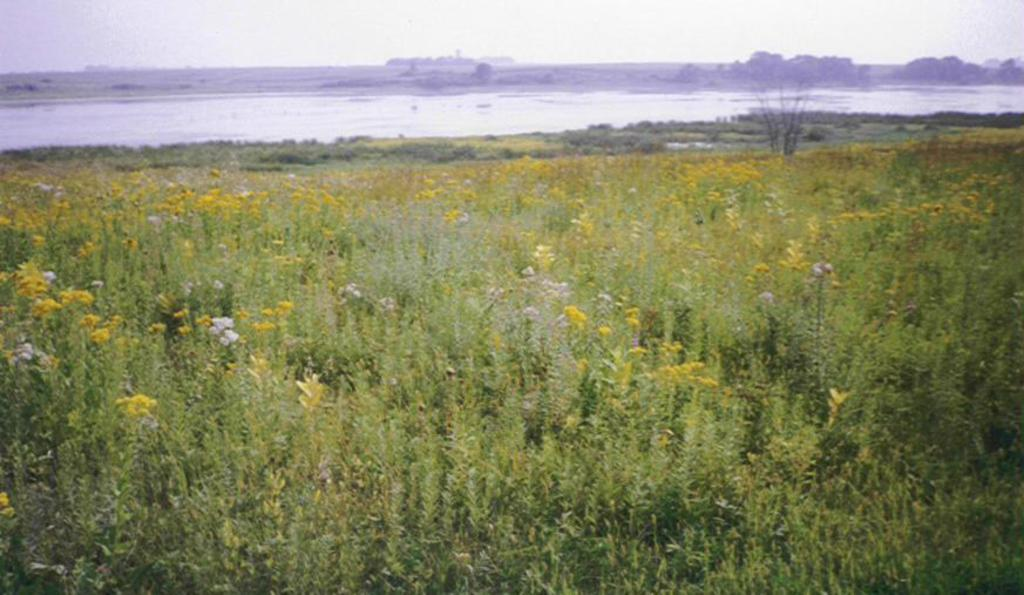What types of plants are present in the image? There are plants with flowers in the image. Can you describe the water visible in the image? The water is visible in the image, although it is not clear how far away it is. Who is the owner of the leaf in the image? There is no leaf mentioned in the image, and therefore no owner can be identified. 